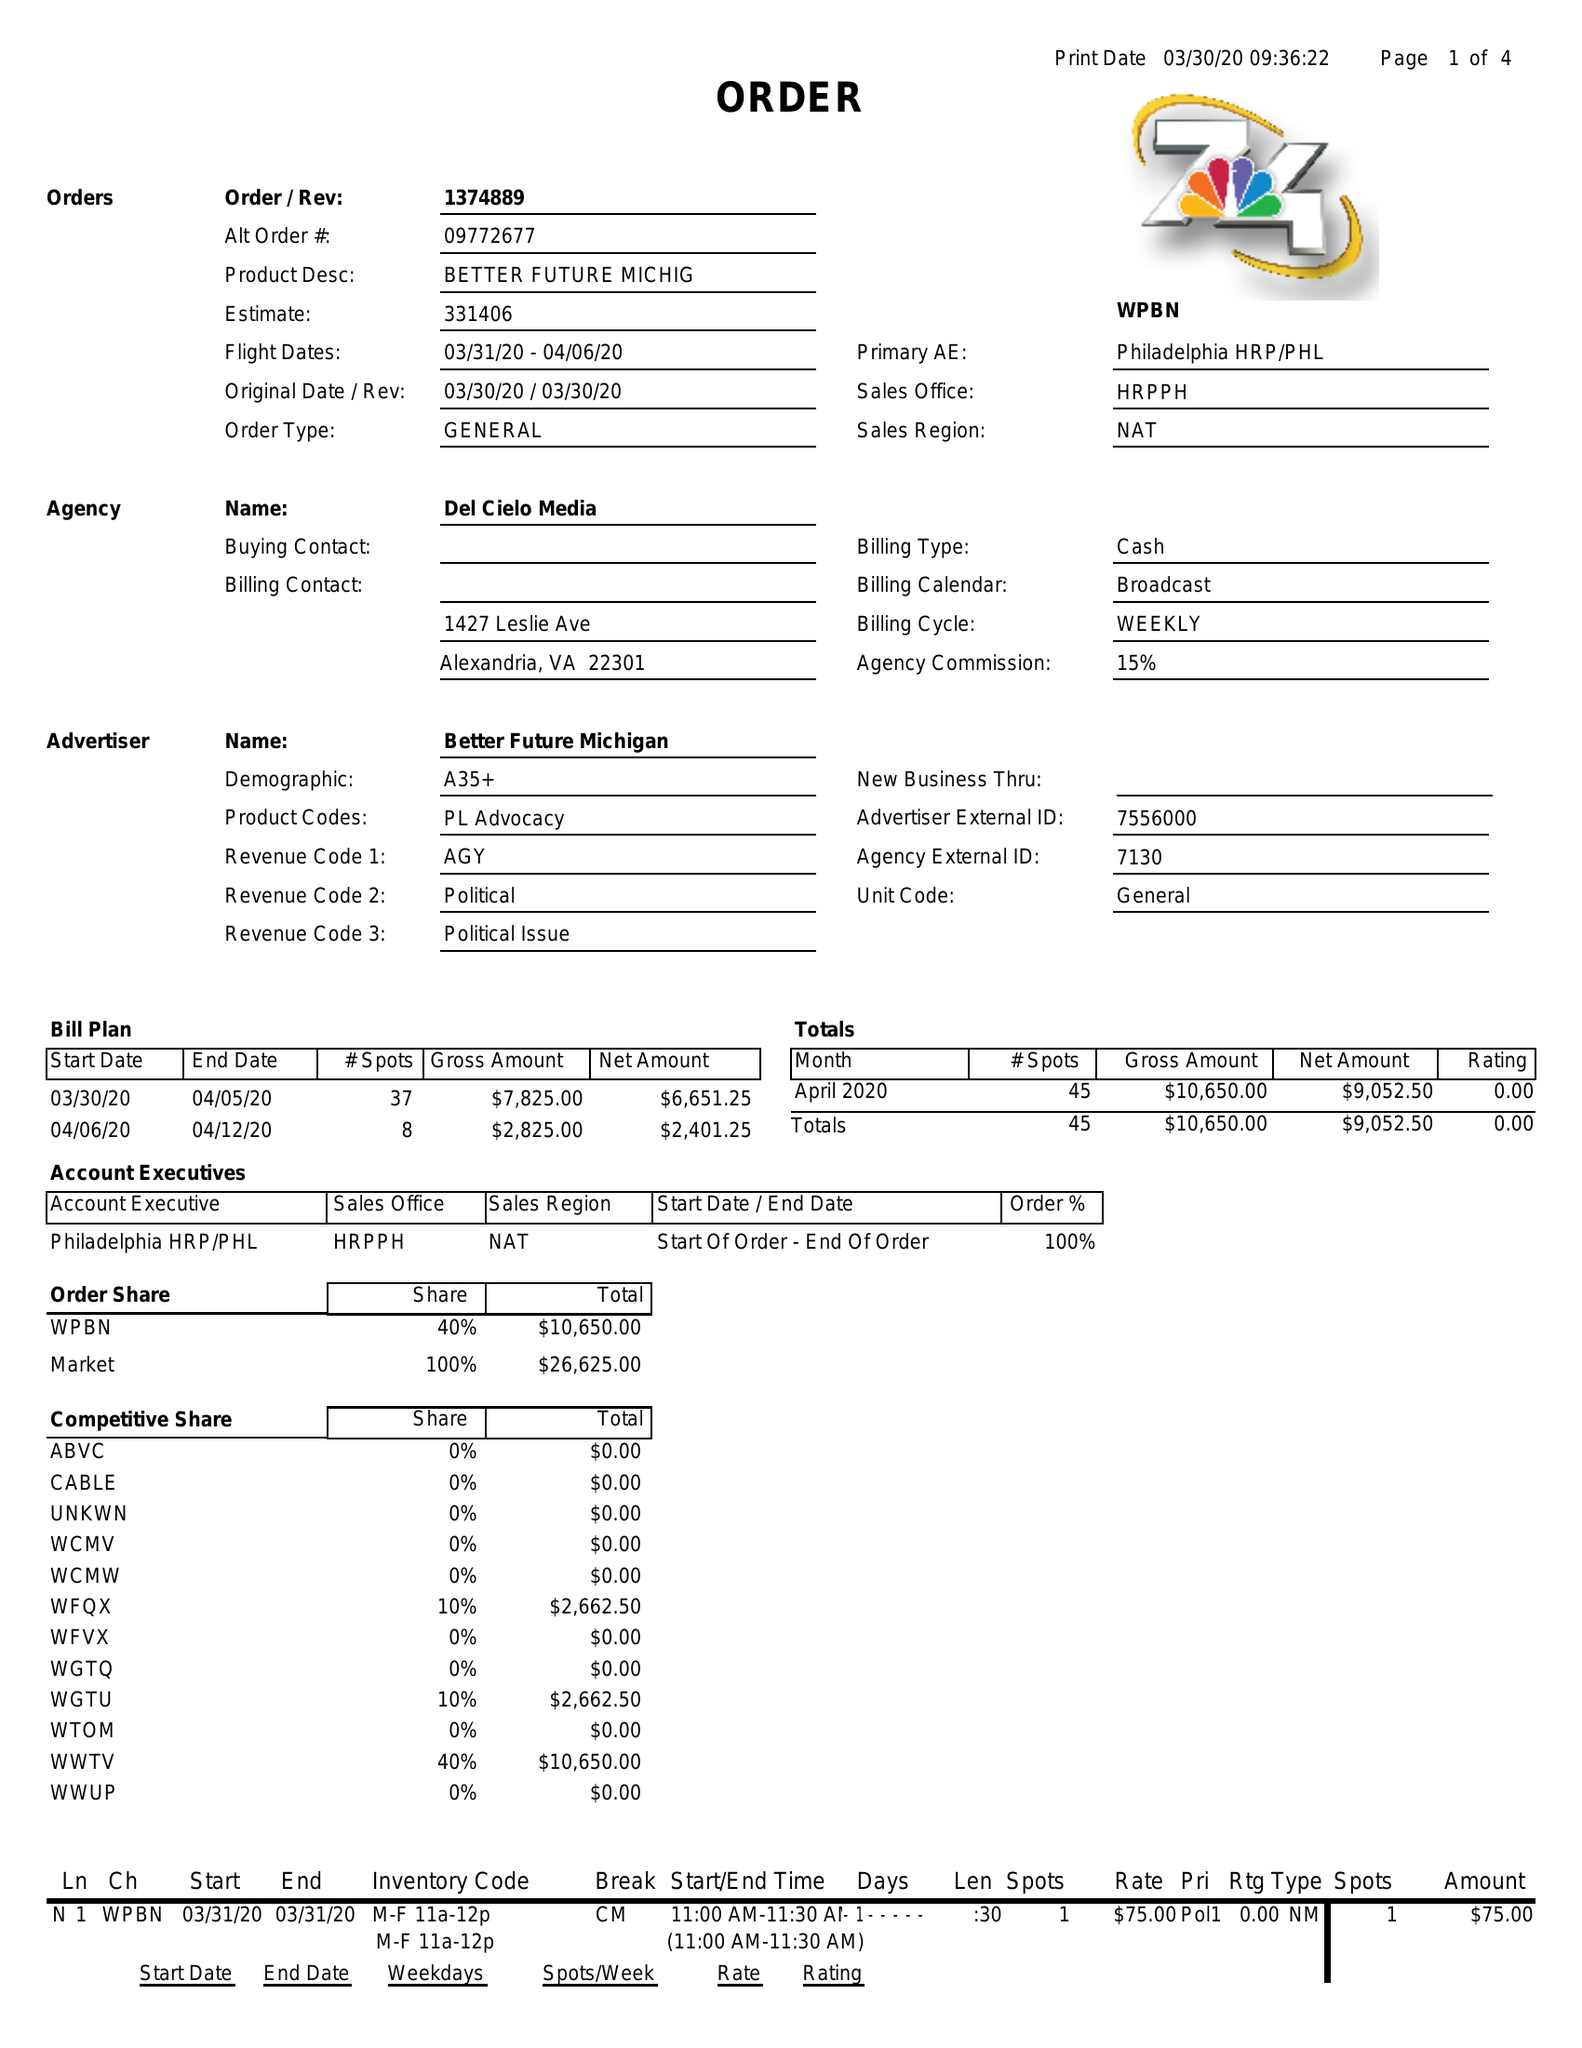What is the value for the contract_num?
Answer the question using a single word or phrase. 1374889 